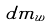<formula> <loc_0><loc_0><loc_500><loc_500>d m _ { w }</formula> 